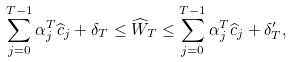<formula> <loc_0><loc_0><loc_500><loc_500>\sum _ { j = 0 } ^ { T - 1 } \alpha ^ { T } _ { j } \widehat { c } _ { j } + \delta _ { T } \leq \widehat { W } _ { T } \leq \sum _ { j = 0 } ^ { T - 1 } \alpha ^ { T } _ { j } \widehat { c } _ { j } + \delta ^ { \prime } _ { T } ,</formula> 